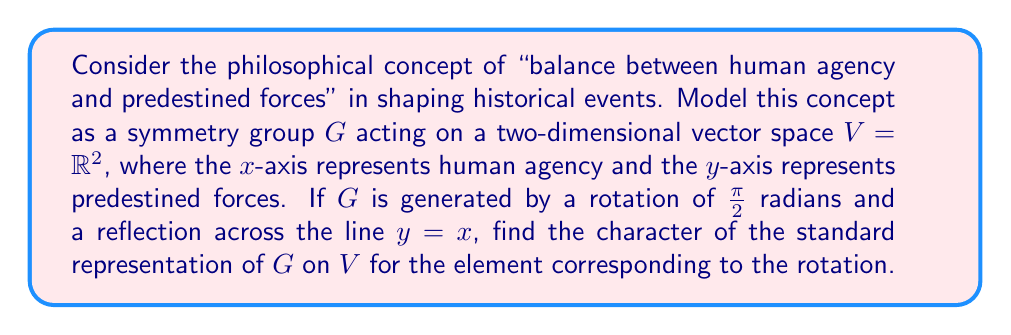What is the answer to this math problem? 1) First, we need to identify the group $G$. The given generators (rotation by $\frac{\pi}{2}$ and reflection across $y=x$) form the dihedral group $D_4$, which has 8 elements.

2) The standard representation $\rho$ of $G$ on $V = \mathbb{R}^2$ assigns to each group element a 2x2 matrix.

3) For the rotation $r$ by $\frac{\pi}{2}$, the matrix is:

   $$R = \begin{pmatrix} 
   0 & -1 \\
   1 & 0
   \end{pmatrix}$$

4) The character $\chi_\rho$ of a representation is the trace of the matrix for each group element.

5) For the rotation $r$:

   $\chi_\rho(r) = \text{Tr}(R) = 0 + 0 = 0$

This result shows that the rotation balances human agency and predestined forces equally, reflecting the philosophical concept of balance in shaping historical events.
Answer: $\chi_\rho(r) = 0$ 